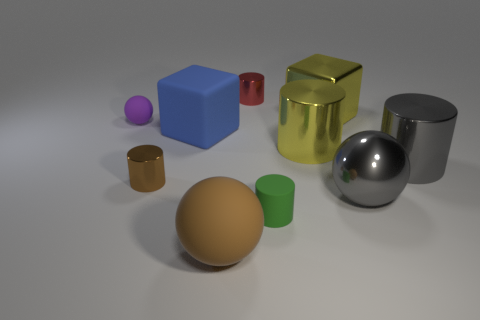There is a block that is to the right of the big rubber sphere; what is its size?
Give a very brief answer. Large. There is a red thing that is the same material as the small brown cylinder; what is its shape?
Your response must be concise. Cylinder. Are there any other things that have the same color as the rubber block?
Keep it short and to the point. No. There is a rubber ball behind the big matte thing that is behind the gray cylinder; what color is it?
Ensure brevity in your answer.  Purple. What number of small things are either purple spheres or blue metallic blocks?
Your response must be concise. 1. There is a large gray thing that is the same shape as the purple object; what material is it?
Your response must be concise. Metal. Are there any other things that have the same material as the purple sphere?
Your response must be concise. Yes. The tiny rubber cylinder is what color?
Provide a succinct answer. Green. Does the matte cylinder have the same color as the big metallic cube?
Make the answer very short. No. What number of red cylinders are in front of the big block behind the large blue rubber thing?
Your answer should be very brief. 0. 